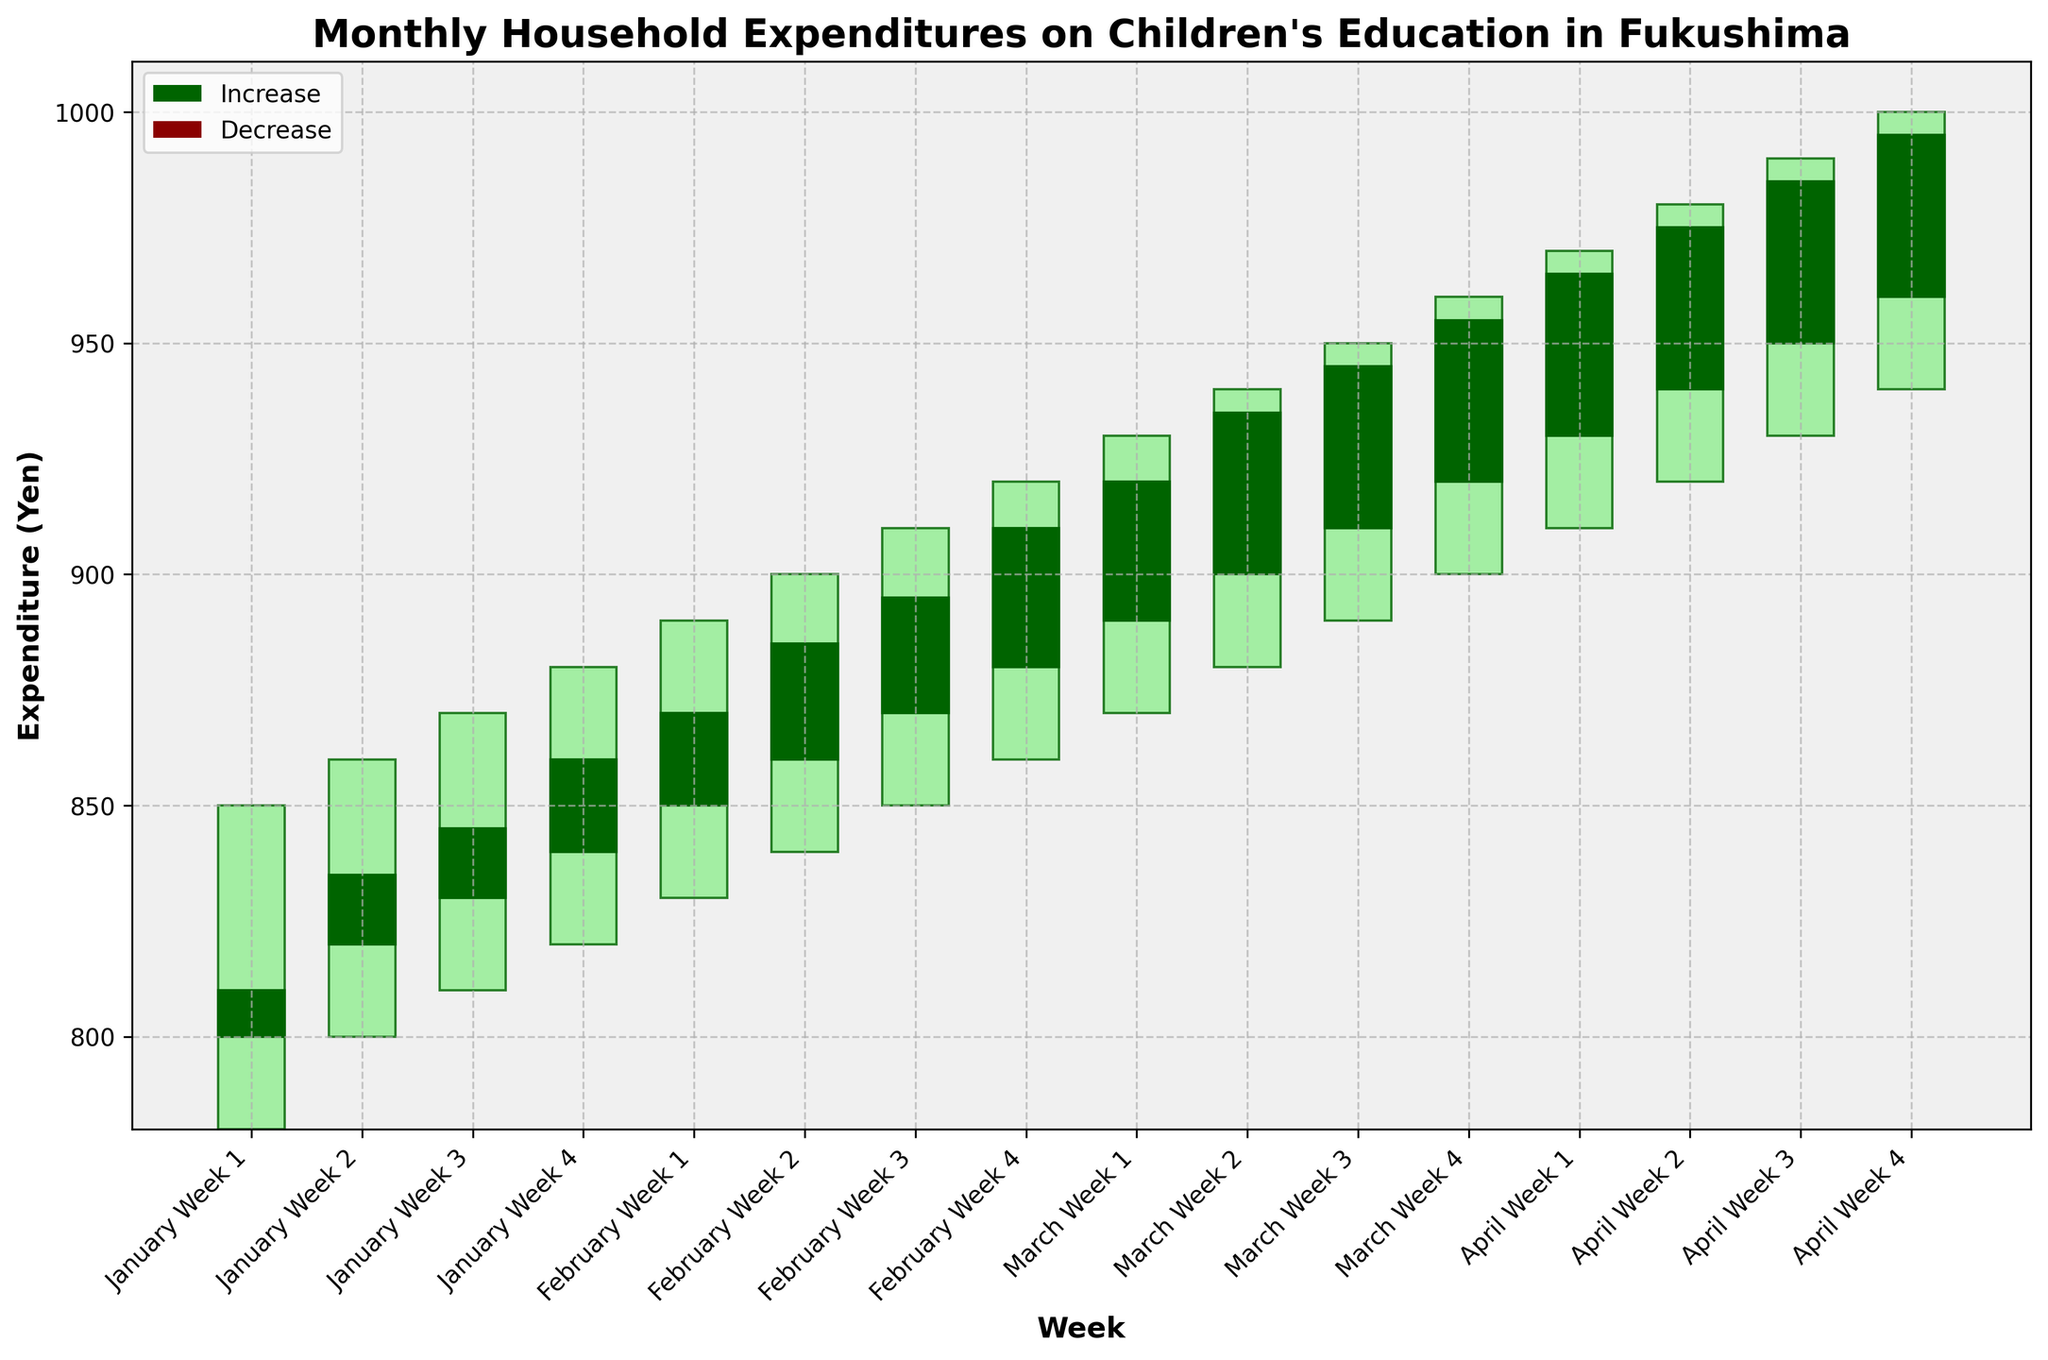What is the title of the figure? The title is typically found at the top of the figure in larger and bold font. This provides a clear description of what the plot represents.
Answer: Monthly Household Expenditures on Children's Education in Fukushima What does the x-axis represent? The x-axis is labeled as "Week" and includes tick labels that show the months and weeks, such as "January Week 1". This indicates the time period for the data points.
Answer: Week What does the color green represent in the candlestick plot? In candlestick plots, the color green typically indicates an increase where the closing value is higher than the opening value.
Answer: Increase How many weeks in total are plotted in the figure? The figure has data points for each week from January to April, with 4 weeks per month. Counting these gives 4 months × 4 weeks = 16 weeks.
Answer: 16 weeks Which week had the highest expenditure in the given data? By examining the candlestick plot, we look for the week with the highest peak value in the 'High' values. The highest expenditure occurs in the week where the 'High' value is 1000 in April Week 4.
Answer: April Week 4 During which weeks did the expenditure decrease compared to the previous week? A decrease is indicated by a red candlestick where the closing value is less than the opening value. Identifying these red candlesticks will tell us the required weeks.
Answer: January Week 1, January Week 2, January Week 3, February Week 1 Which month showed a consistent increase in expenditures throughout all weeks? A consistent increase means each week's closing value is higher than the previous week's closing value. By examining the plot, we see this pattern in April.
Answer: April What is the difference between the highest and lowest expenditure in March? Reviewing March, the highest expenditure occurs at 960 (High in March Week 4) and the lowest at 870 (Low in March Week 1). The difference is 960 - 870.
Answer: 90 Yen What is the average closing expenditure in February? To find this, sum up all the closing values for February and divide by the number of weeks. (870 + 885 + 895 + 910) / 4.
Answer: 890 Yen Comparing January Week 1 and April Week 1, which week had a higher closing expenditure and by how much? Look at the closing values of January Week 1 (810) and April Week 1 (965). Subtract the value of January Week 1 from April Week 1 (965 - 810).
Answer: April Week 1 by 155 Yen 